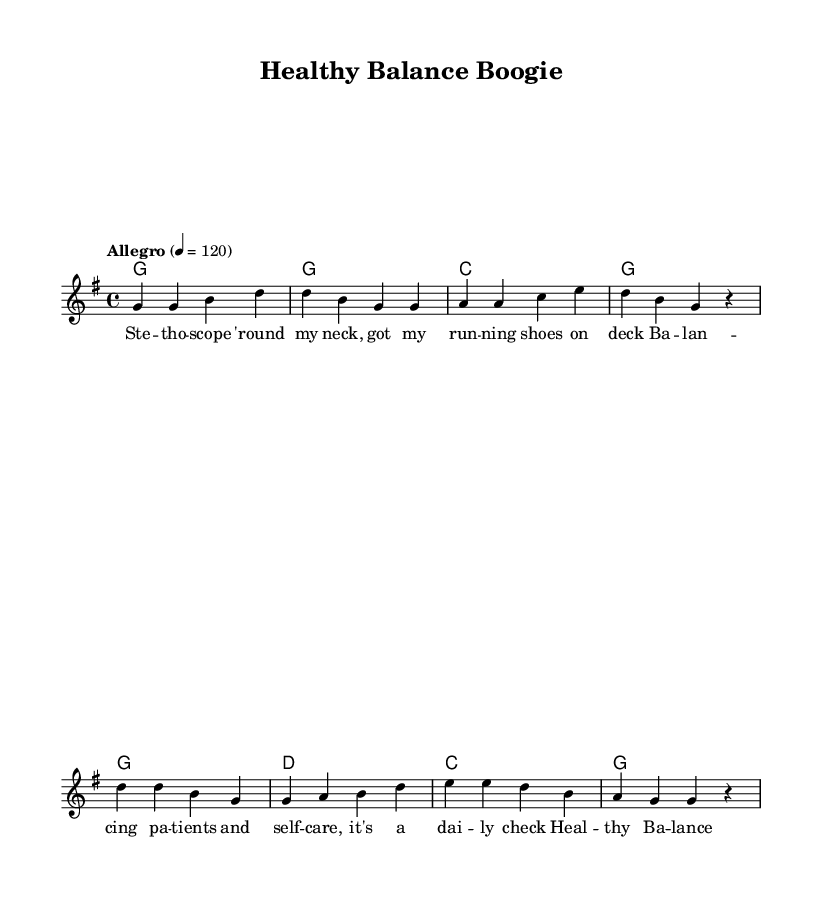What is the key signature of this music? The key signature is G major, which has one sharp (F#) in the key signature. This can be identified by looking at the beginning of the staff where the key signature is indicated.
Answer: G major What is the time signature of this music? The time signature is 4/4, indicated by the notation placed at the beginning of the score. This means there are four beats in a measure and the quarter note gets one beat.
Answer: 4/4 What is the tempo marking used in this piece? The tempo marking is "Allegro," meaning the piece should be played at a fast and lively pace. The numerical indication of 120 suggests the beats per minute.
Answer: Allegro How many measures are in the chorus section? The chorus section contains four measures. This can be determined by counting from the start to the end of the chorus part in the score.
Answer: 4 Which chord is played in the first measure? The chord played in the first measure is G major. This is indicated in the harmonies section where the chord is specified at the start of the score.
Answer: G What phrase best captures the theme of this song? The phrase that captures the theme is "Healthy Balance Boogie" as this is both the title and reflects the song's emphasis on balancing wellness and work in the healthcare industry.
Answer: Healthy Balance Boogie How does the melody relate to the lyrics in the chorus? The melody rises and falls in a lively manner, matching the uplifting feel of the lyrics "Nurturing others while we feed our soul." This relationship creates an engaging and positive atmosphere that reflects the song's theme.
Answer: Uplifting melody 